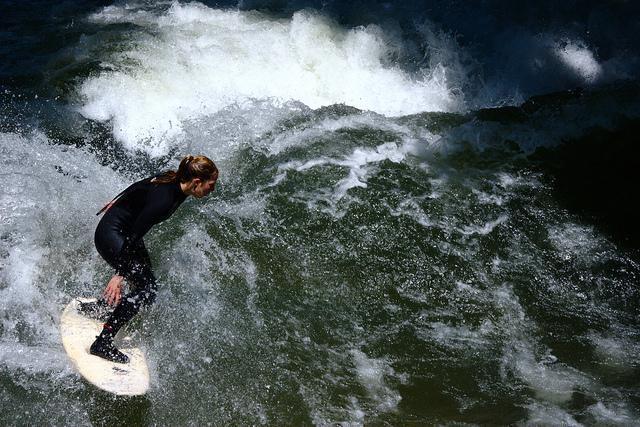How many chairs are on the left side of the table?
Give a very brief answer. 0. 